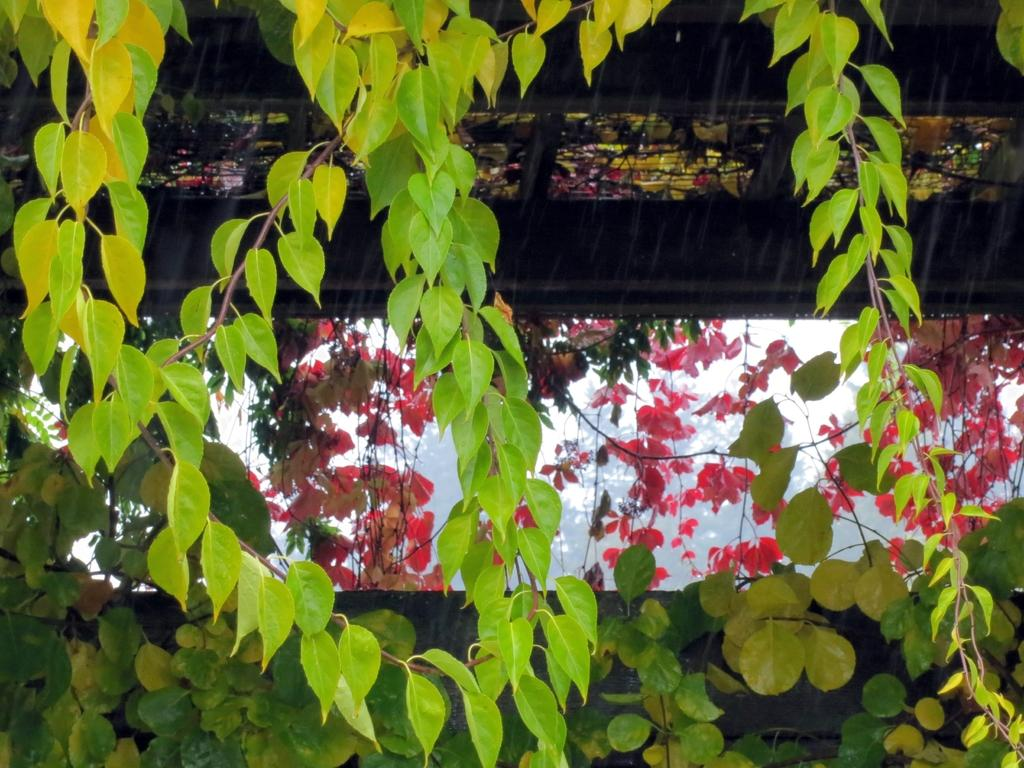What type of vegetation can be seen in the image? There are leaves in the image. What color are the leaves? The leaves are green and pink in color. What type of ornament is hanging from the leaves in the image? There is no ornament present in the image; it only features leaves. 